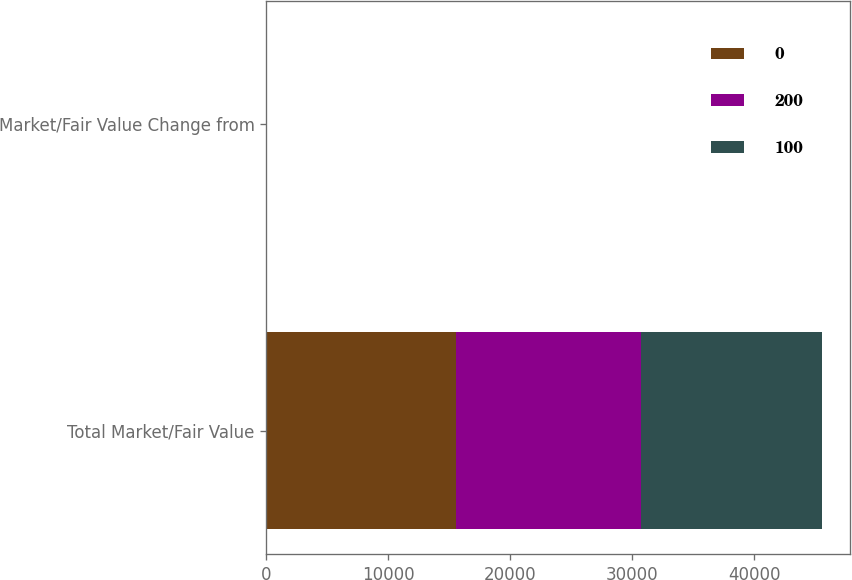Convert chart to OTSL. <chart><loc_0><loc_0><loc_500><loc_500><stacked_bar_chart><ecel><fcel>Total Market/Fair Value<fcel>Market/Fair Value Change from<nl><fcel>0<fcel>15563.2<fcel>5.1<nl><fcel>200<fcel>15194.2<fcel>2.6<nl><fcel>100<fcel>14808.5<fcel>0<nl></chart> 